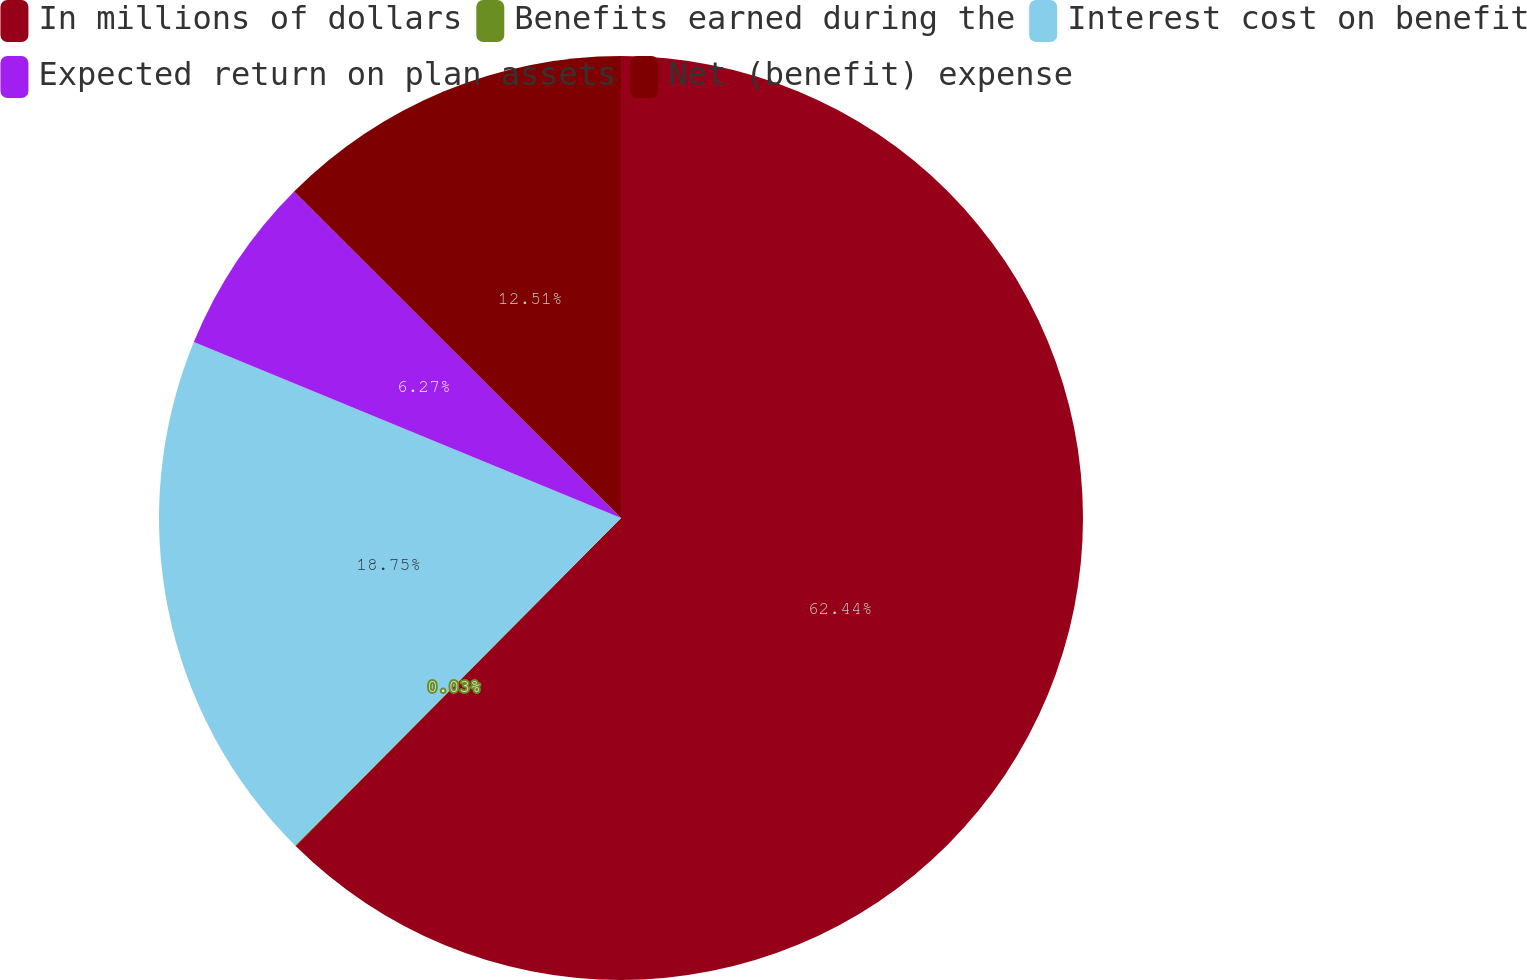<chart> <loc_0><loc_0><loc_500><loc_500><pie_chart><fcel>In millions of dollars<fcel>Benefits earned during the<fcel>Interest cost on benefit<fcel>Expected return on plan assets<fcel>Net (benefit) expense<nl><fcel>62.43%<fcel>0.03%<fcel>18.75%<fcel>6.27%<fcel>12.51%<nl></chart> 